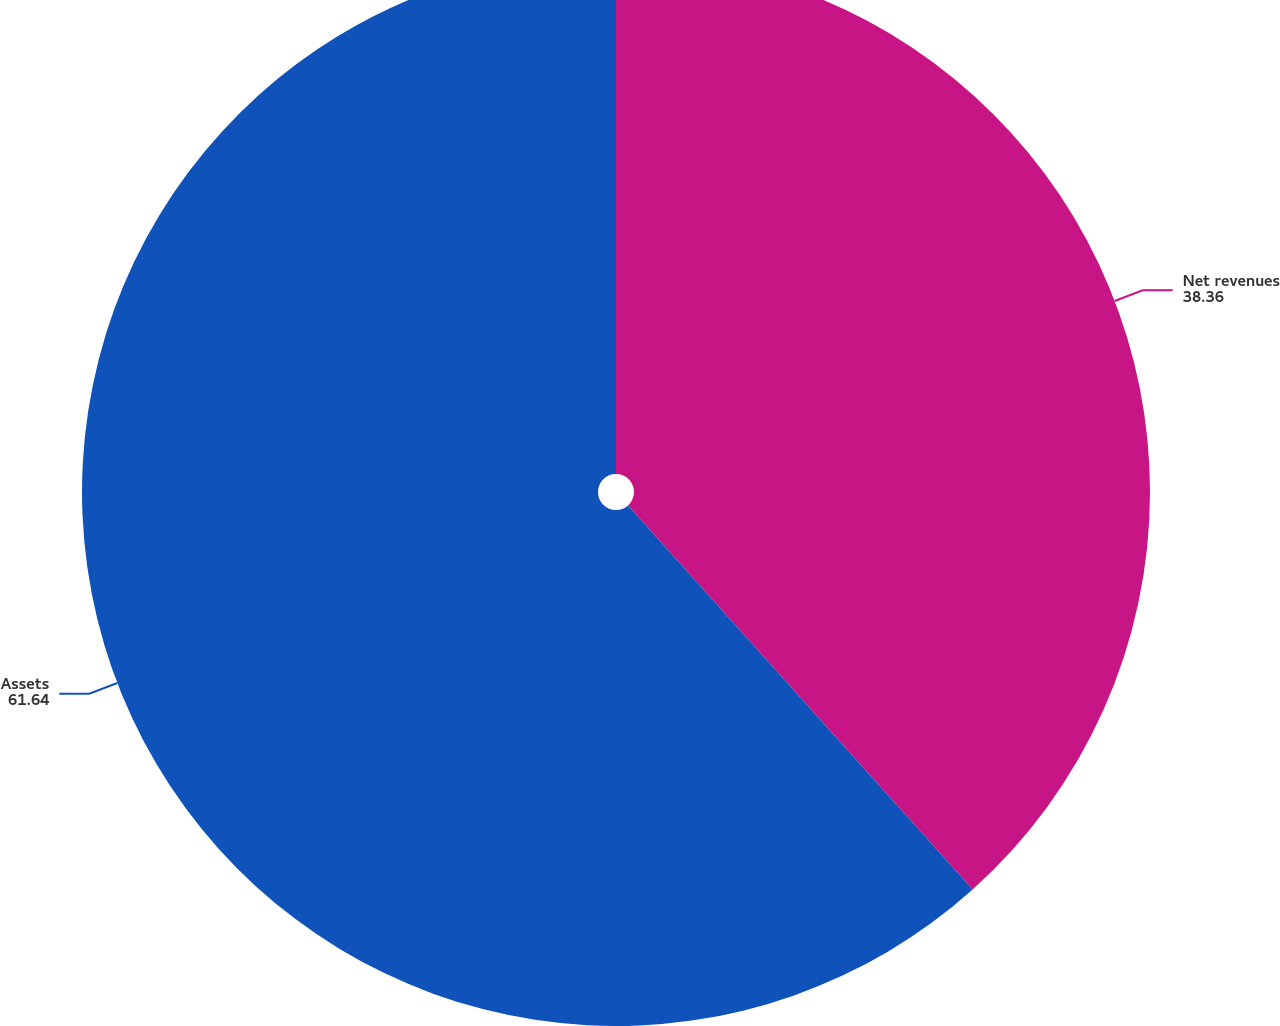Convert chart. <chart><loc_0><loc_0><loc_500><loc_500><pie_chart><fcel>Net revenues<fcel>Assets<nl><fcel>38.36%<fcel>61.64%<nl></chart> 